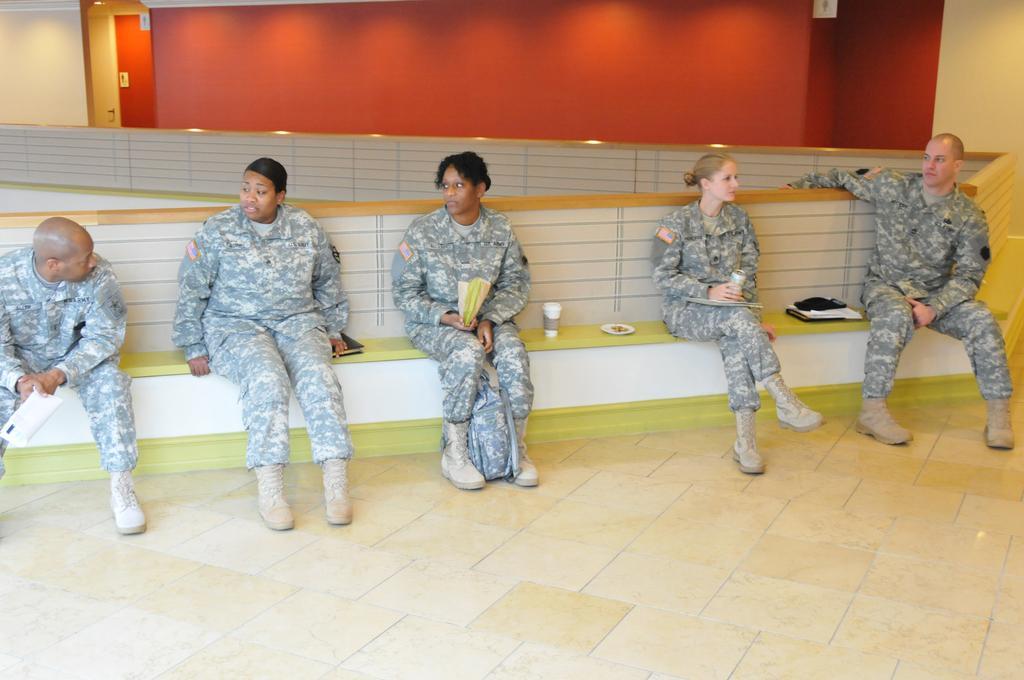How would you summarize this image in a sentence or two? In this image, we can see people sitting on the bench and are wearing uniforms and holding objects and we can see a plate, glass and some papers on the bench and there is a bag. In the background, there is a wall and we can see some boards and lights. At the bottom, there is a floor. 